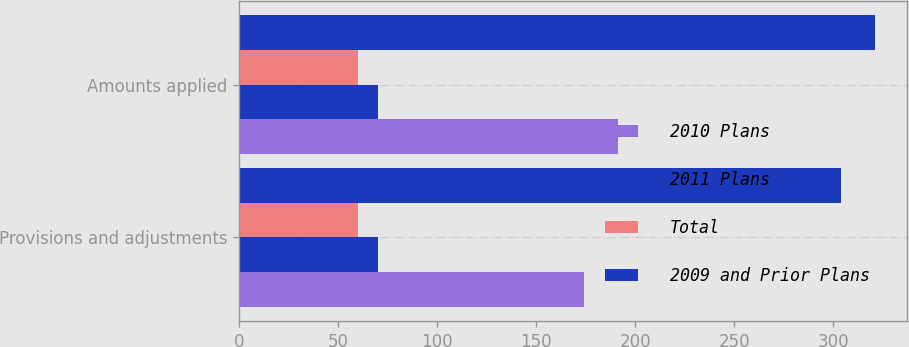Convert chart to OTSL. <chart><loc_0><loc_0><loc_500><loc_500><stacked_bar_chart><ecel><fcel>Provisions and adjustments<fcel>Amounts applied<nl><fcel>2010 Plans<fcel>174<fcel>191<nl><fcel>2011 Plans<fcel>70<fcel>70<nl><fcel>Total<fcel>60<fcel>60<nl><fcel>2009 and Prior Plans<fcel>304<fcel>321<nl></chart> 